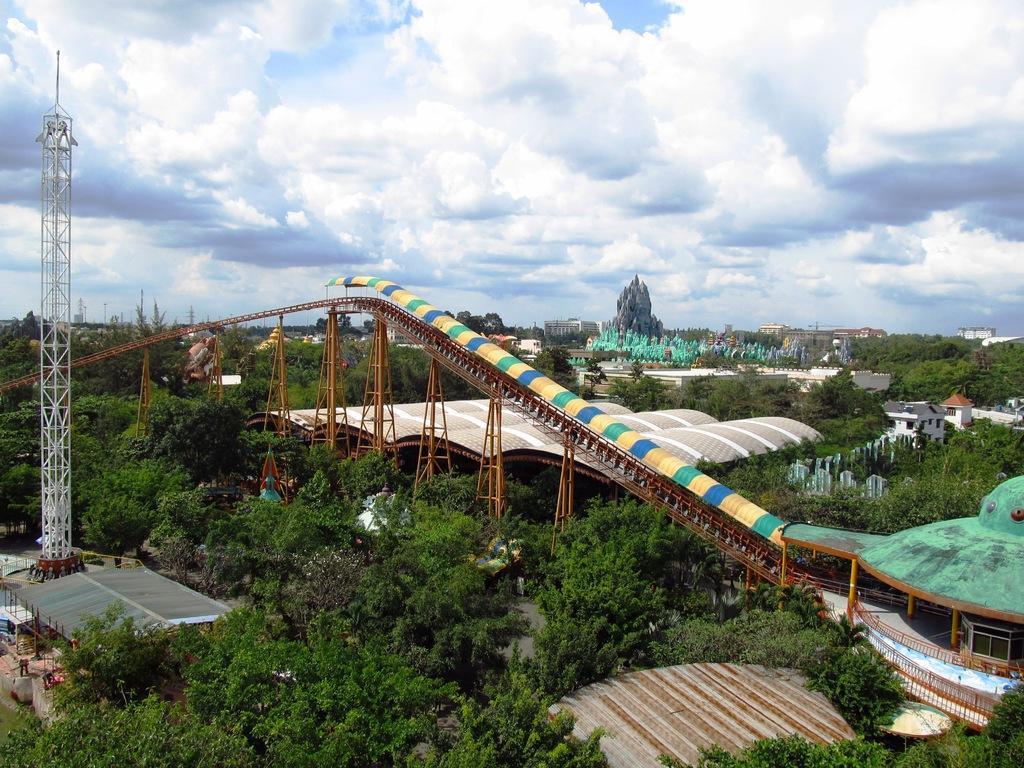Could you give a brief overview of what you see in this image? In this image we can see few trees, there are some buildings, sheds and towers, also we can see a bridge and in the background, we can see the sky with clouds. 